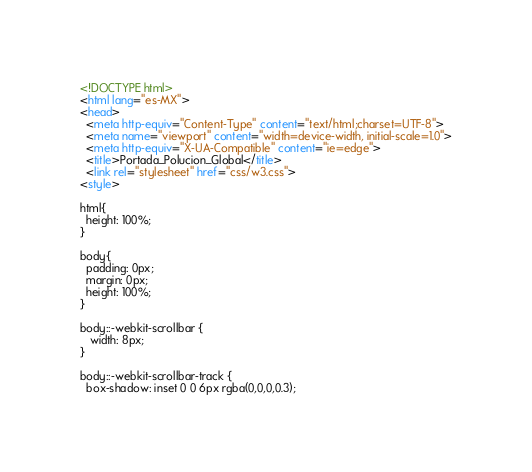<code> <loc_0><loc_0><loc_500><loc_500><_HTML_><!DOCTYPE html>
<html lang="es-MX">
<head>
  <meta http-equiv="Content-Type" content="text/html;charset=UTF-8">
  <meta name="viewport" content="width=device-width, initial-scale=1.0">
  <meta http-equiv="X-UA-Compatible" content="ie=edge">
  <title>Portada_Polucion_Global</title>
  <link rel="stylesheet" href="css/w3.css">
<style>

html{
  height: 100%;
}

body{
  padding: 0px;
  margin: 0px;
  height: 100%;
}

body::-webkit-scrollbar {
   width: 8px;
}

body::-webkit-scrollbar-track {
  box-shadow: inset 0 0 6px rgba(0,0,0,0.3);</code> 